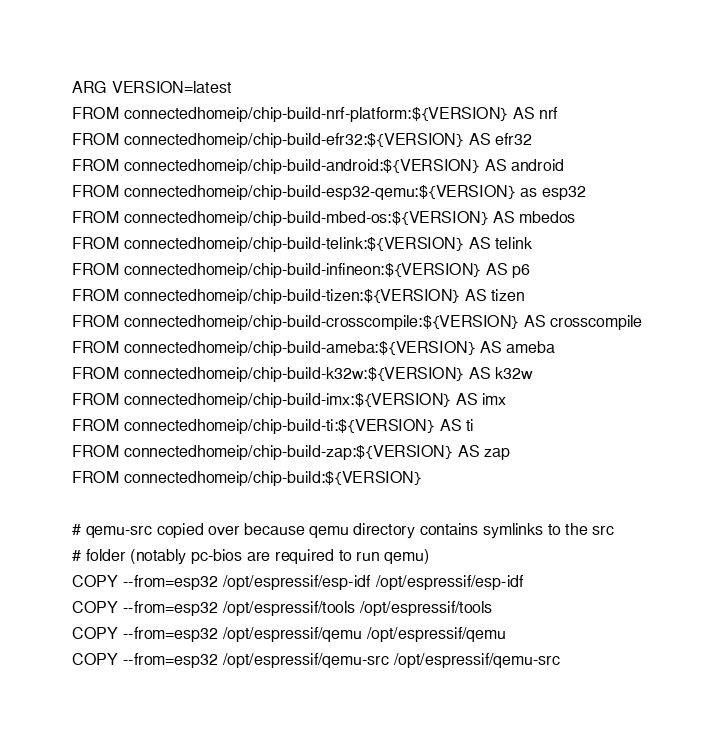<code> <loc_0><loc_0><loc_500><loc_500><_Dockerfile_>ARG VERSION=latest
FROM connectedhomeip/chip-build-nrf-platform:${VERSION} AS nrf
FROM connectedhomeip/chip-build-efr32:${VERSION} AS efr32
FROM connectedhomeip/chip-build-android:${VERSION} AS android
FROM connectedhomeip/chip-build-esp32-qemu:${VERSION} as esp32
FROM connectedhomeip/chip-build-mbed-os:${VERSION} AS mbedos
FROM connectedhomeip/chip-build-telink:${VERSION} AS telink
FROM connectedhomeip/chip-build-infineon:${VERSION} AS p6
FROM connectedhomeip/chip-build-tizen:${VERSION} AS tizen
FROM connectedhomeip/chip-build-crosscompile:${VERSION} AS crosscompile
FROM connectedhomeip/chip-build-ameba:${VERSION} AS ameba
FROM connectedhomeip/chip-build-k32w:${VERSION} AS k32w
FROM connectedhomeip/chip-build-imx:${VERSION} AS imx
FROM connectedhomeip/chip-build-ti:${VERSION} AS ti
FROM connectedhomeip/chip-build-zap:${VERSION} AS zap
FROM connectedhomeip/chip-build:${VERSION}

# qemu-src copied over because qemu directory contains symlinks to the src
# folder (notably pc-bios are required to run qemu)
COPY --from=esp32 /opt/espressif/esp-idf /opt/espressif/esp-idf
COPY --from=esp32 /opt/espressif/tools /opt/espressif/tools
COPY --from=esp32 /opt/espressif/qemu /opt/espressif/qemu
COPY --from=esp32 /opt/espressif/qemu-src /opt/espressif/qemu-src
</code> 